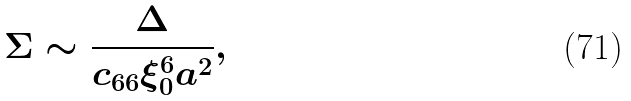Convert formula to latex. <formula><loc_0><loc_0><loc_500><loc_500>\Sigma \sim \frac { \Delta } { c _ { 6 6 } \xi _ { 0 } ^ { 6 } a ^ { 2 } } ,</formula> 